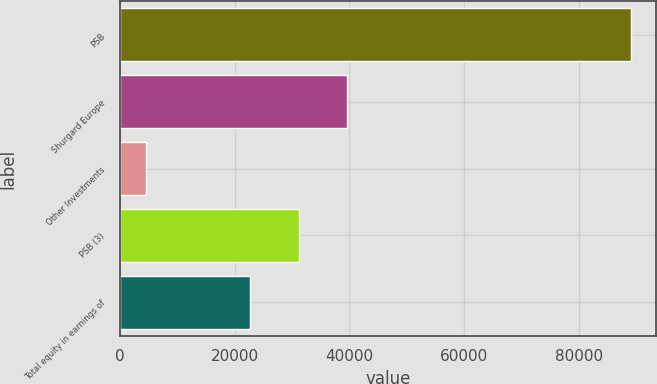Convert chart to OTSL. <chart><loc_0><loc_0><loc_500><loc_500><bar_chart><fcel>PSB<fcel>Shurgard Europe<fcel>Other Investments<fcel>PSB (3)<fcel>Total equity in earnings of<nl><fcel>89067<fcel>39657.3<fcel>4626<fcel>31213.2<fcel>22769.1<nl></chart> 